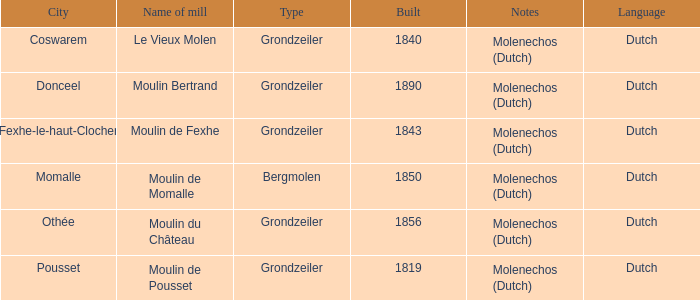What is the Location of the Moulin Bertrand Mill? Donceel. 